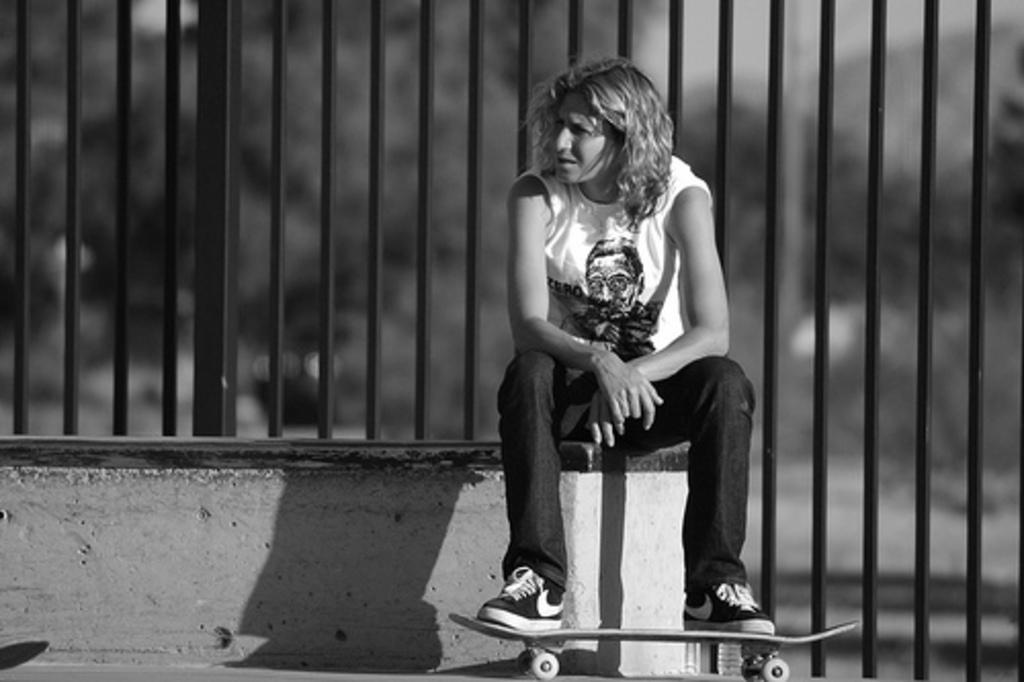What is the color scheme of the image? The image is black and white. What is the person in the image doing? The person is sitting and holding a skateboard. What type of architectural feature can be seen in the image? There are iron grilles in the image. How would you describe the background of the image? The background of the image is blurred. What shape are the eggs in the image? There are no eggs present in the image. What type of office furniture can be seen in the image? There is no office furniture present in the image. 